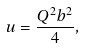<formula> <loc_0><loc_0><loc_500><loc_500>u = \frac { Q ^ { 2 } b ^ { 2 } } { 4 } ,</formula> 